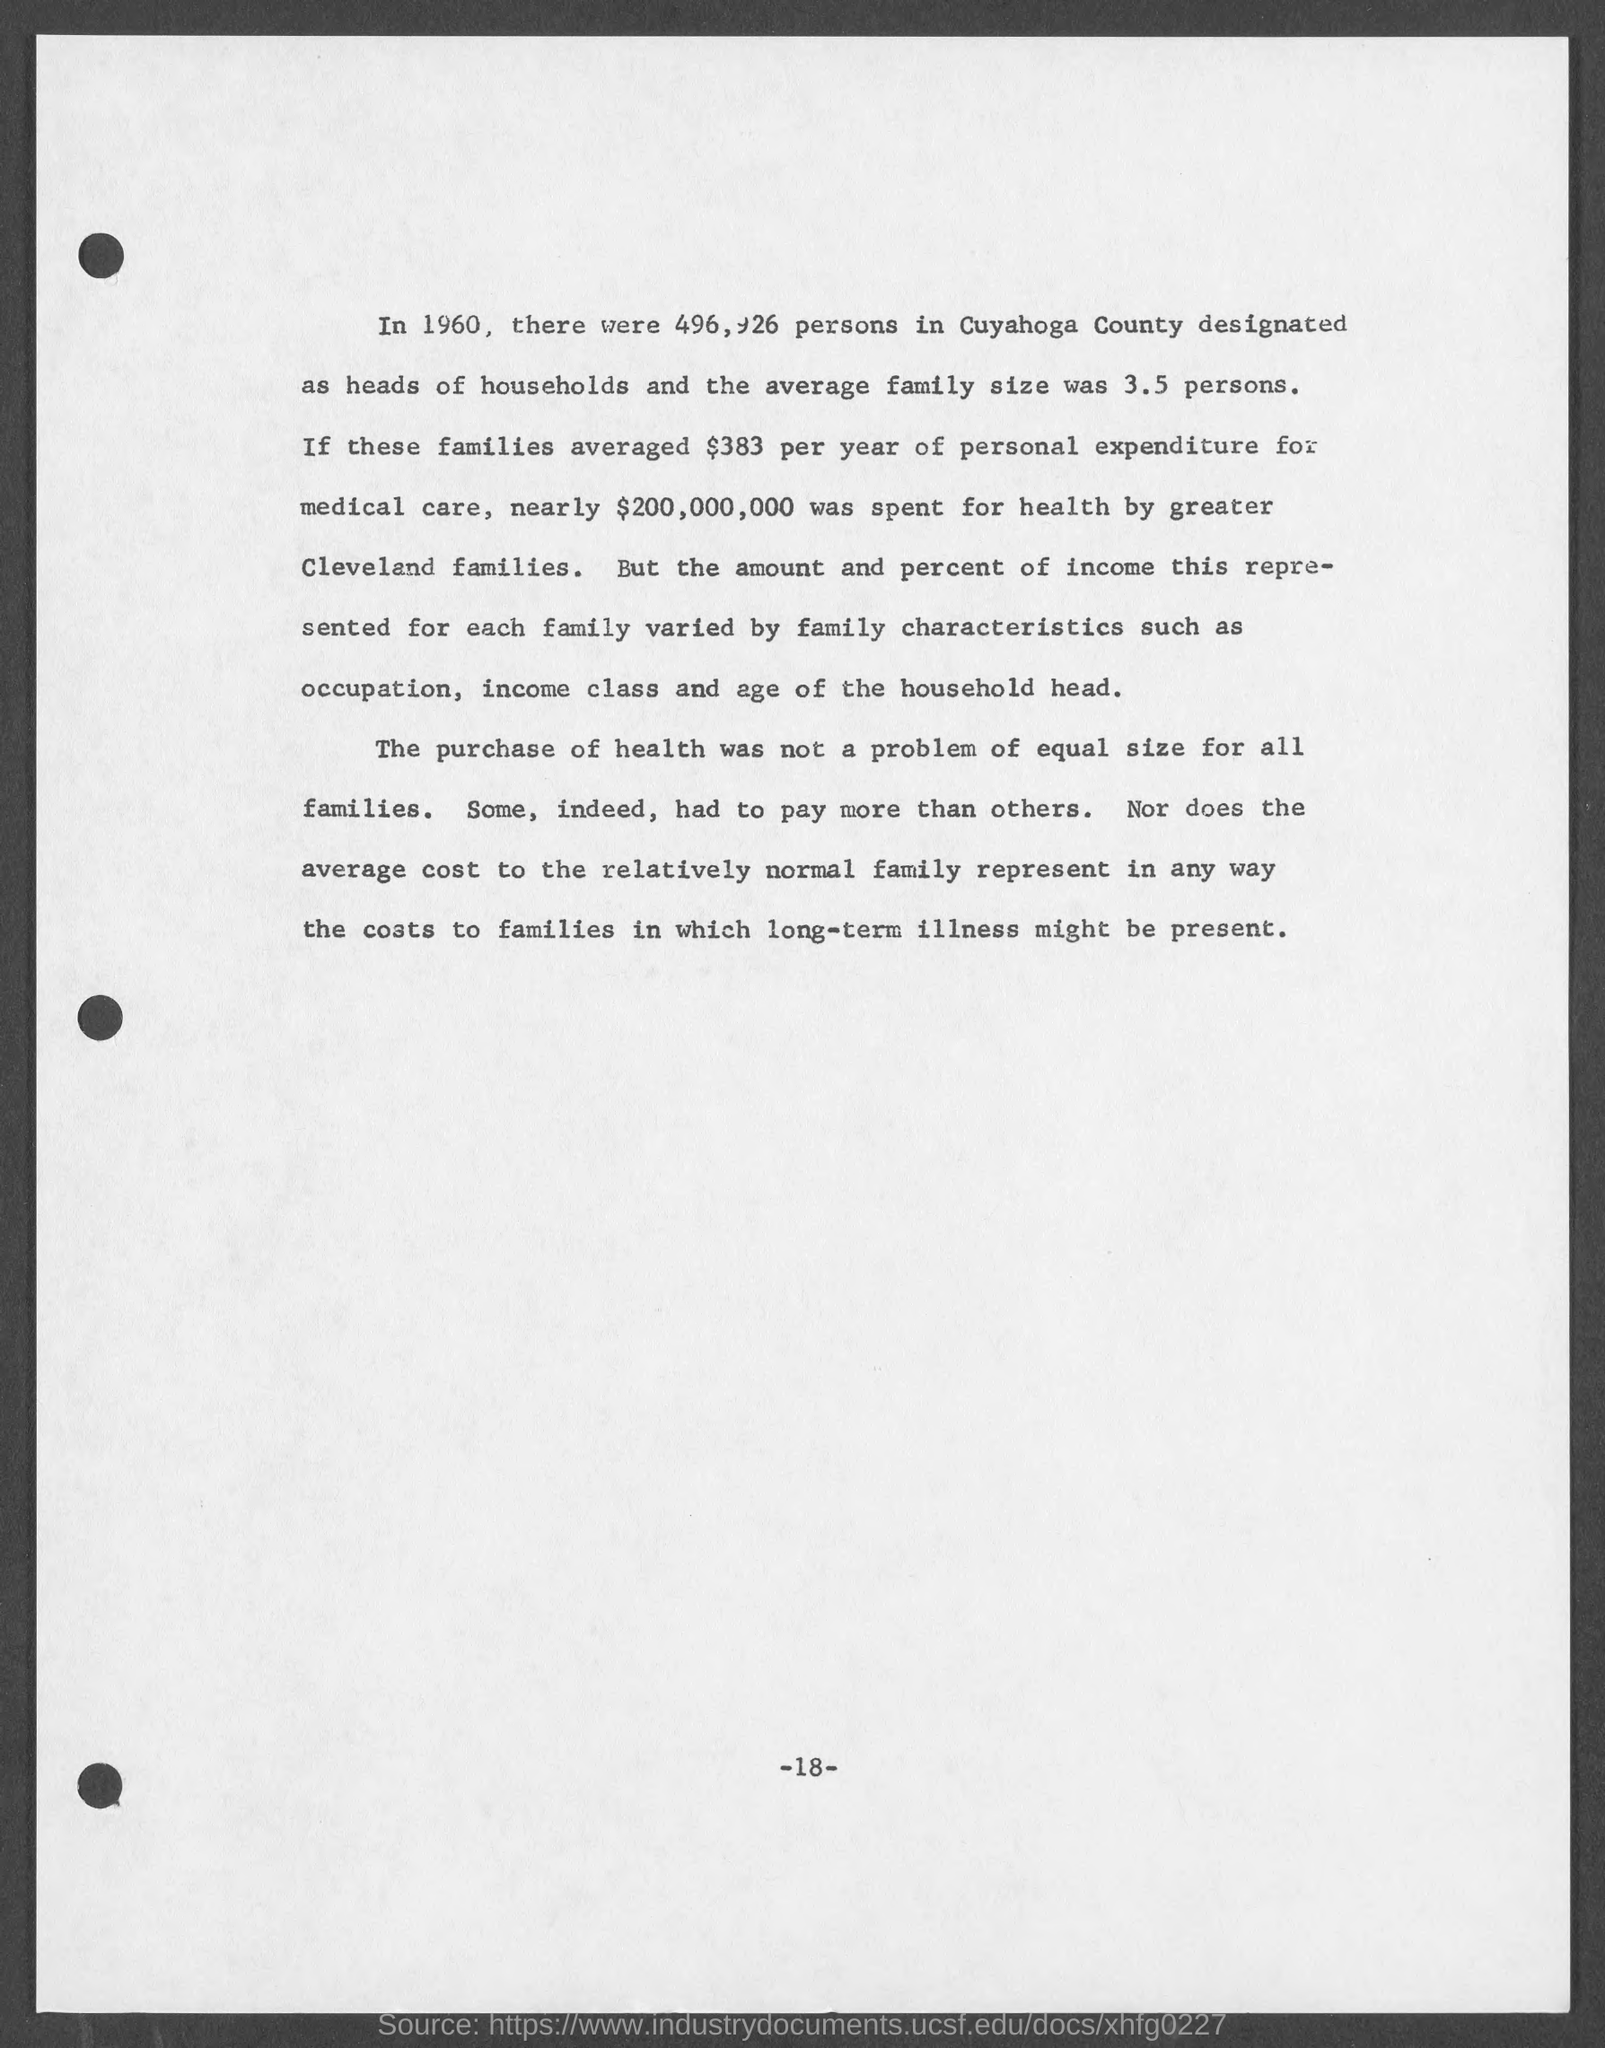What is the number at bottom of the page ?
Provide a succinct answer. 18. 